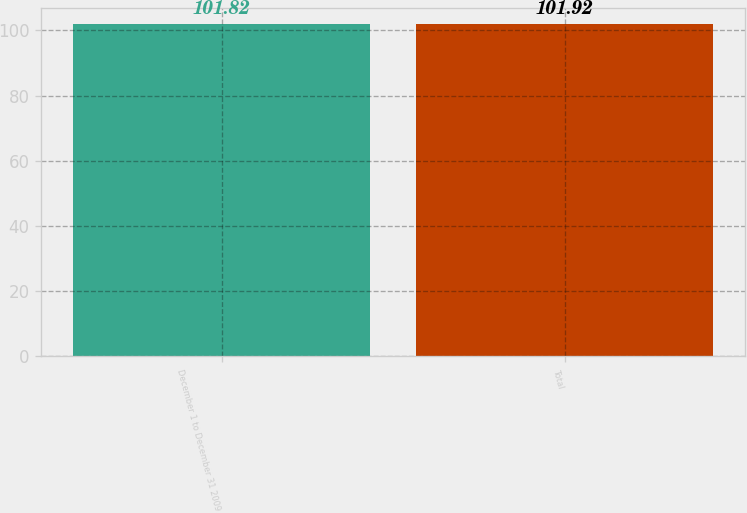Convert chart. <chart><loc_0><loc_0><loc_500><loc_500><bar_chart><fcel>December 1 to December 31 2009<fcel>Total<nl><fcel>101.82<fcel>101.92<nl></chart> 